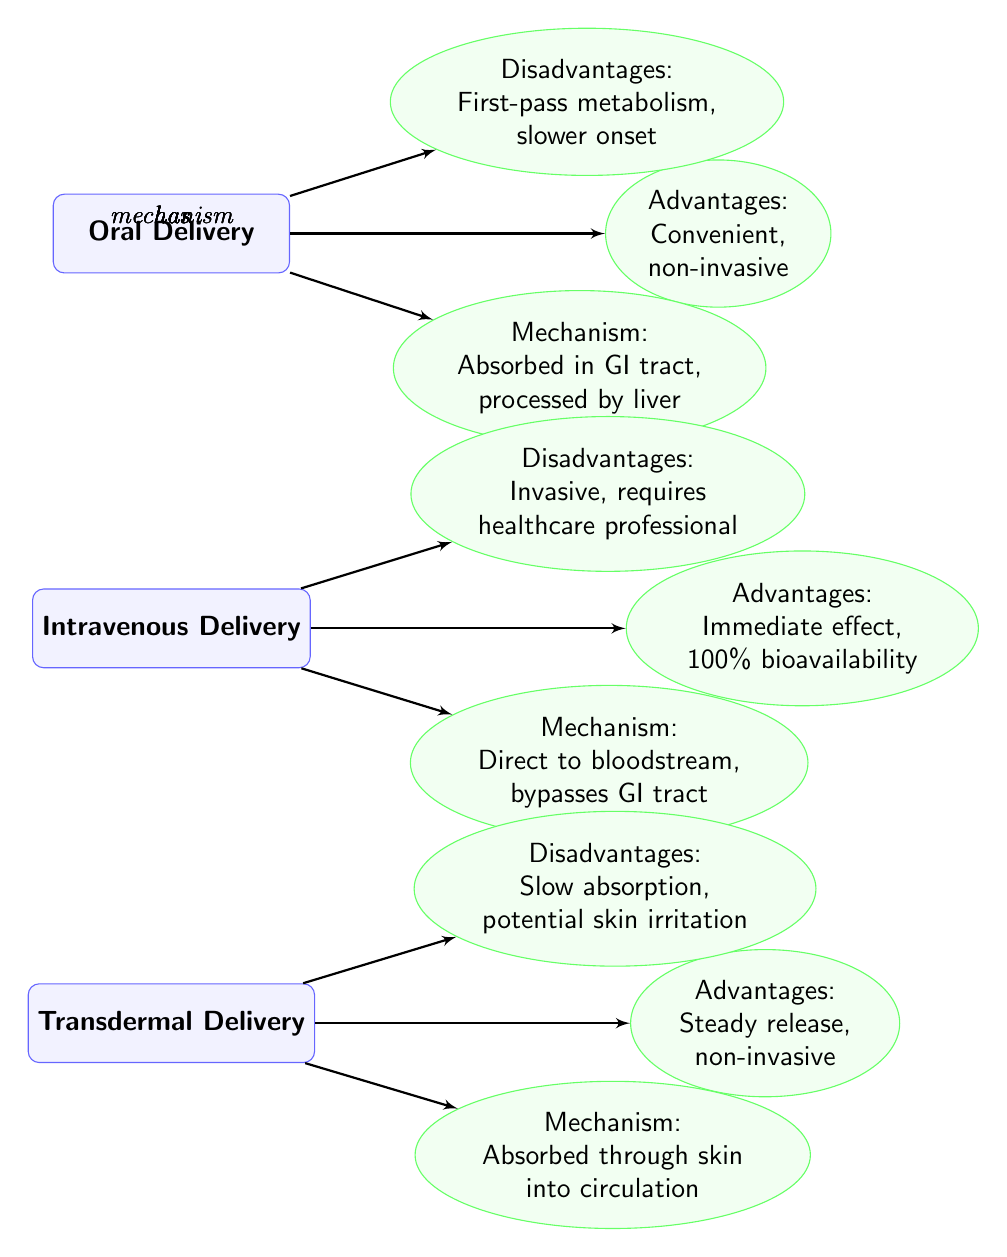What are the advantages of oral delivery? The diagram lists the advantages of oral delivery in the respective node, which states "Convenient, non-invasive." Therefore, the advantages are clearly defined in the visual layout of the diagram.
Answer: Convenient, non-invasive How many drug delivery methods are compared in the diagram? By counting the method nodes in the diagram, we see three listed: Oral Delivery, Intravenous Delivery, and Transdermal Delivery. Therefore, the total number of methods is three.
Answer: 3 What mechanism is associated with intravenous delivery? The mechanism for intravenous delivery is stated in the mechanism node connected to it, which describes the process as "Direct to bloodstream, bypasses GI tract." This shows the direct nature of the method's action.
Answer: Direct to bloodstream, bypasses GI tract Which delivery method has the disadvantage of slow absorption? The disadvantage node for transdermal delivery specifies "Slow absorption, potential skin irritation." This is a clear indication that transdermal delivery is the method associated with slow absorption.
Answer: Transdermal Delivery Which method is described as having 100% bioavailability? The advantages node for intravenous delivery states "Immediate effect, 100% bioavailability." Thus, it is explicitly clear that intravenous delivery has this characteristic.
Answer: Intravenous Delivery What is a common disadvantage of both oral and transdermal delivery methods? The oral delivery has "First-pass metabolism, slower onset" while transdermal has "Slow absorption, potential skin irritation." In reviewing both nodes, the common theme centers around slower processes; however, strictly in terms of shared disadvantages, there isn't a direct overlapping disadvantage. Thus, further analysis shows they both involve slower processes in some capacity but with different specific disadvantages. Therefore, reasoning yields that no direct disadvantage exists between them since it is different.
Answer: None What does the mechanism for transdermal delivery explain about its absorption? The mechanism node for transdermal delivery states, "Absorbed through skin into circulation." This indicates that the absorption occurs via the skin, highlighting a unique transfer method compared to others.
Answer: Absorbed through skin into circulation 